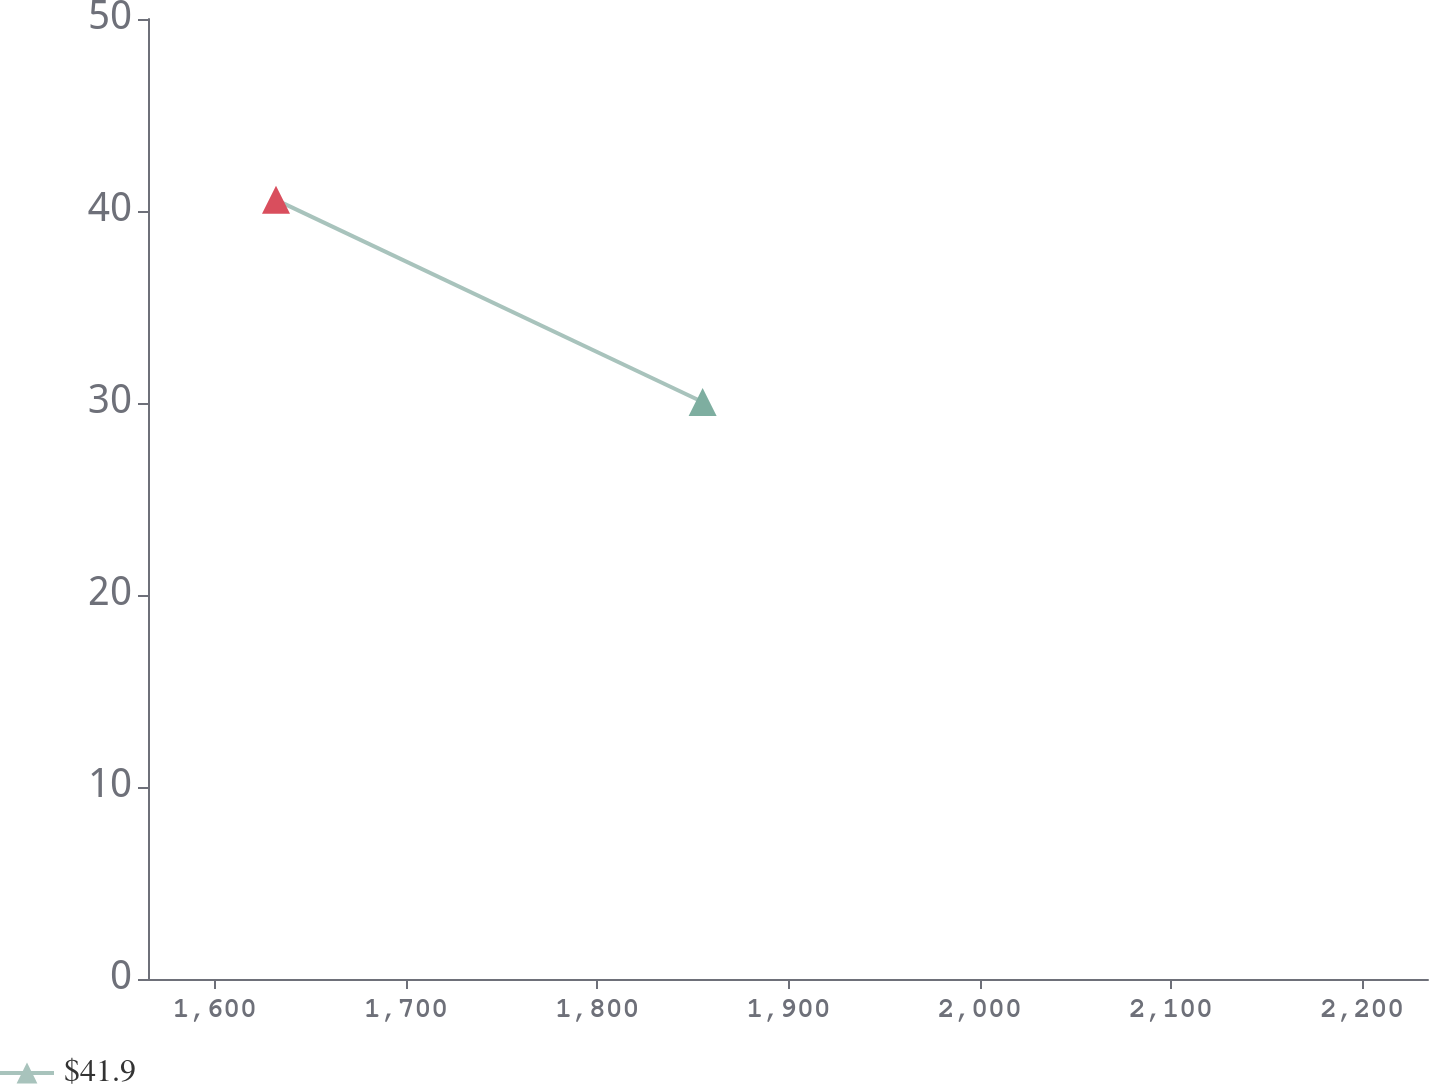Convert chart to OTSL. <chart><loc_0><loc_0><loc_500><loc_500><line_chart><ecel><fcel>$41.9<nl><fcel>1631.97<fcel>40.58<nl><fcel>1855.09<fcel>30.05<nl><fcel>2238.59<fcel>32.31<nl><fcel>2301.39<fcel>28.21<nl></chart> 